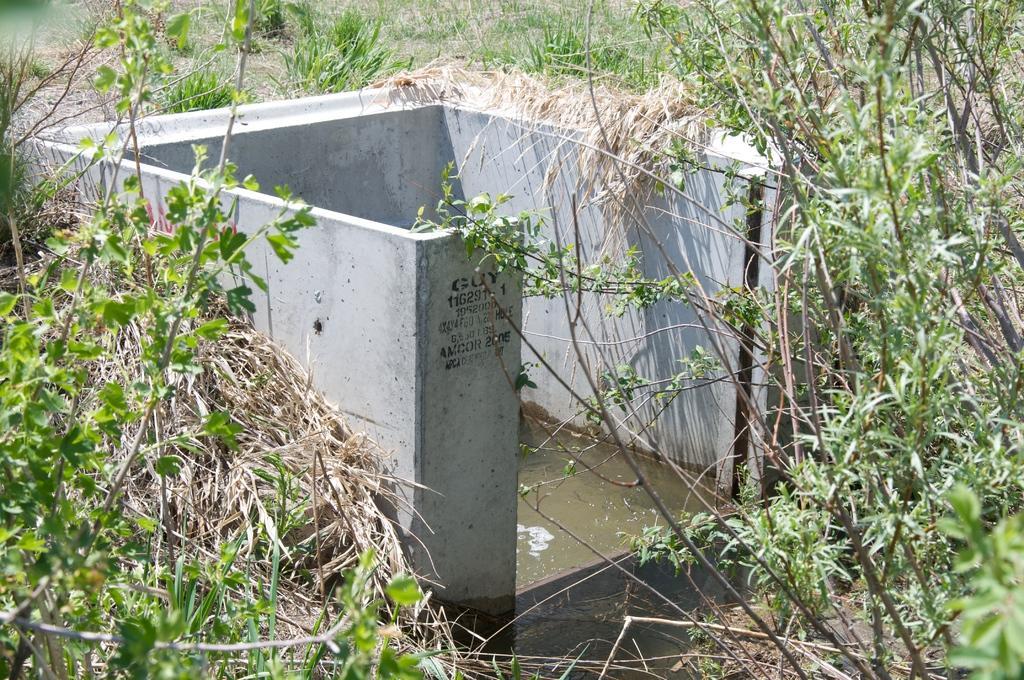In one or two sentences, can you explain what this image depicts? In this image we can see cement walls, water and in the background, we can see group of plants. 